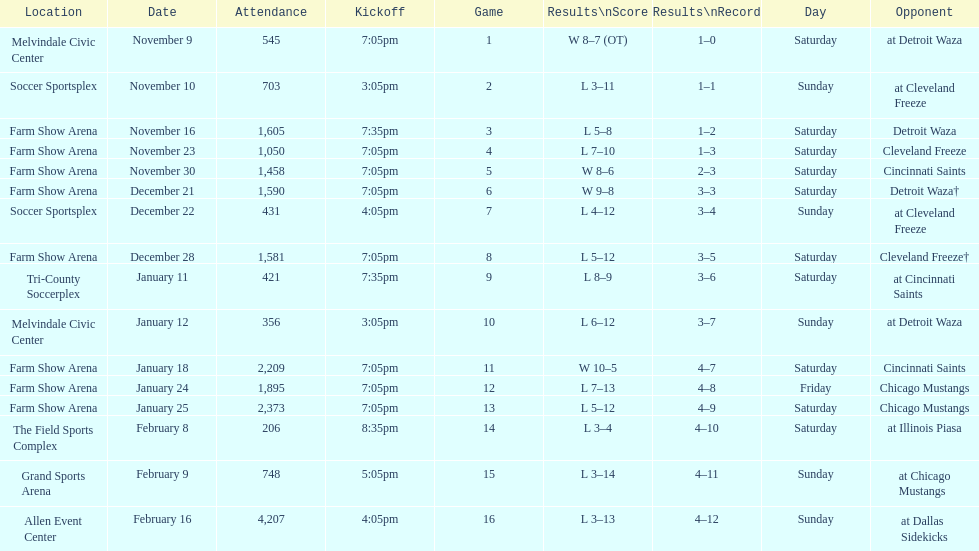Which opponent is listed first in the table? Detroit Waza. 